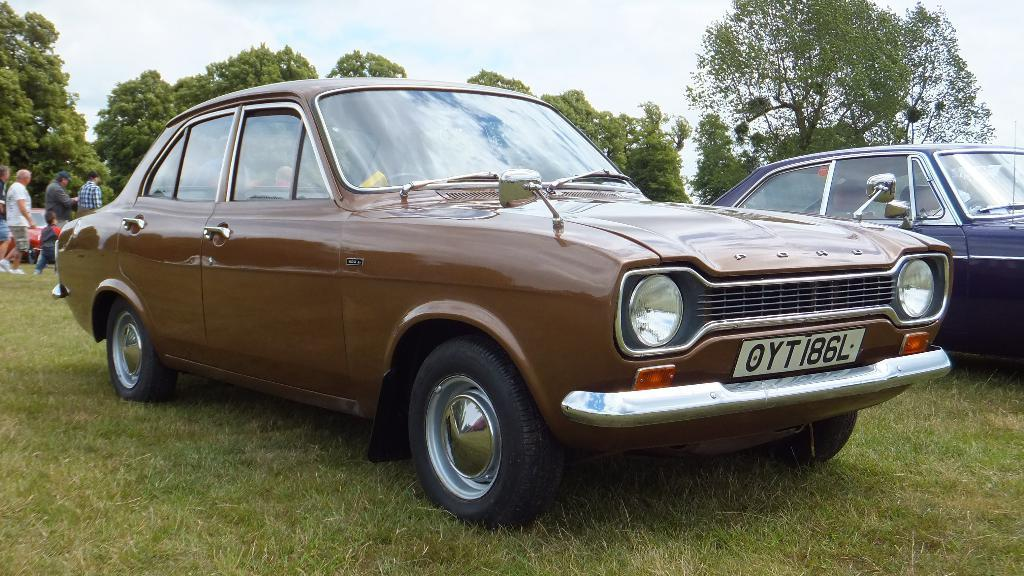What are the people in the image doing? The people in the image are walking on the ground. What vehicles can be seen in the image? There are three cars parked on the ground in the image. What type of vegetation is present in the image? There are trees and grass in the image. What is visible at the top of the image? The sky is visible at the top of the image. Where is the minister standing in the image? There is no minister present in the image. What type of bushes can be seen in the image? There are no bushes mentioned in the provided facts; the image only includes trees and grass. 